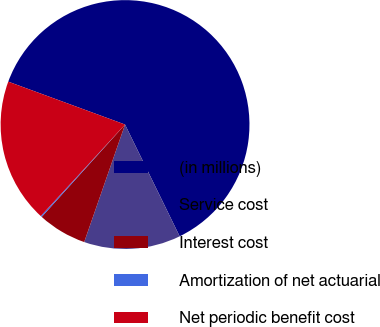Convert chart. <chart><loc_0><loc_0><loc_500><loc_500><pie_chart><fcel>(in millions)<fcel>Service cost<fcel>Interest cost<fcel>Amortization of net actuarial<fcel>Net periodic benefit cost<nl><fcel>62.17%<fcel>12.56%<fcel>6.36%<fcel>0.16%<fcel>18.76%<nl></chart> 